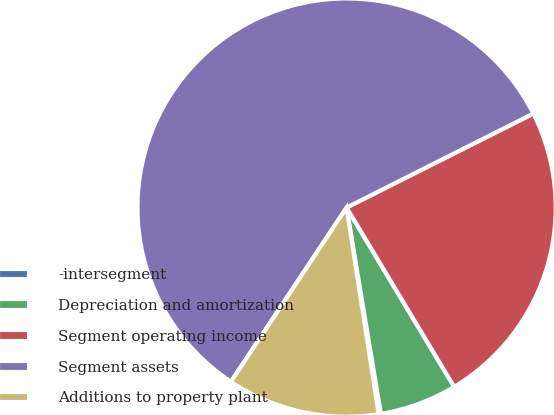Convert chart to OTSL. <chart><loc_0><loc_0><loc_500><loc_500><pie_chart><fcel>-intersegment<fcel>Depreciation and amortization<fcel>Segment operating income<fcel>Segment assets<fcel>Additions to property plant<nl><fcel>0.17%<fcel>5.98%<fcel>23.82%<fcel>58.25%<fcel>11.78%<nl></chart> 